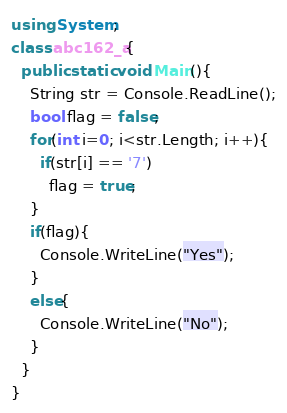Convert code to text. <code><loc_0><loc_0><loc_500><loc_500><_C#_>using System;
class abc162_a{
  public static void Main(){
    String str = Console.ReadLine();
    bool flag = false;
    for(int i=0; i<str.Length; i++){
      if(str[i] == '7')
        flag = true;
    }
    if(flag){
      Console.WriteLine("Yes");
    }
    else{
      Console.WriteLine("No");
    }
  }
}
</code> 